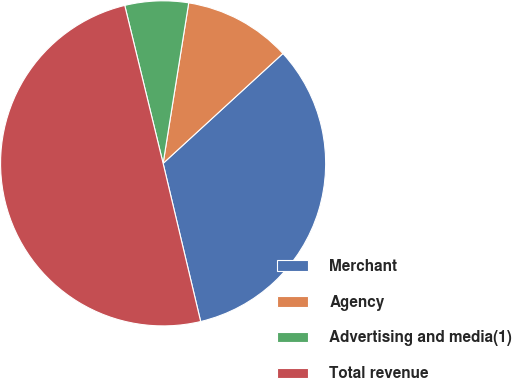Convert chart. <chart><loc_0><loc_0><loc_500><loc_500><pie_chart><fcel>Merchant<fcel>Agency<fcel>Advertising and media(1)<fcel>Total revenue<nl><fcel>33.1%<fcel>10.67%<fcel>6.31%<fcel>49.92%<nl></chart> 